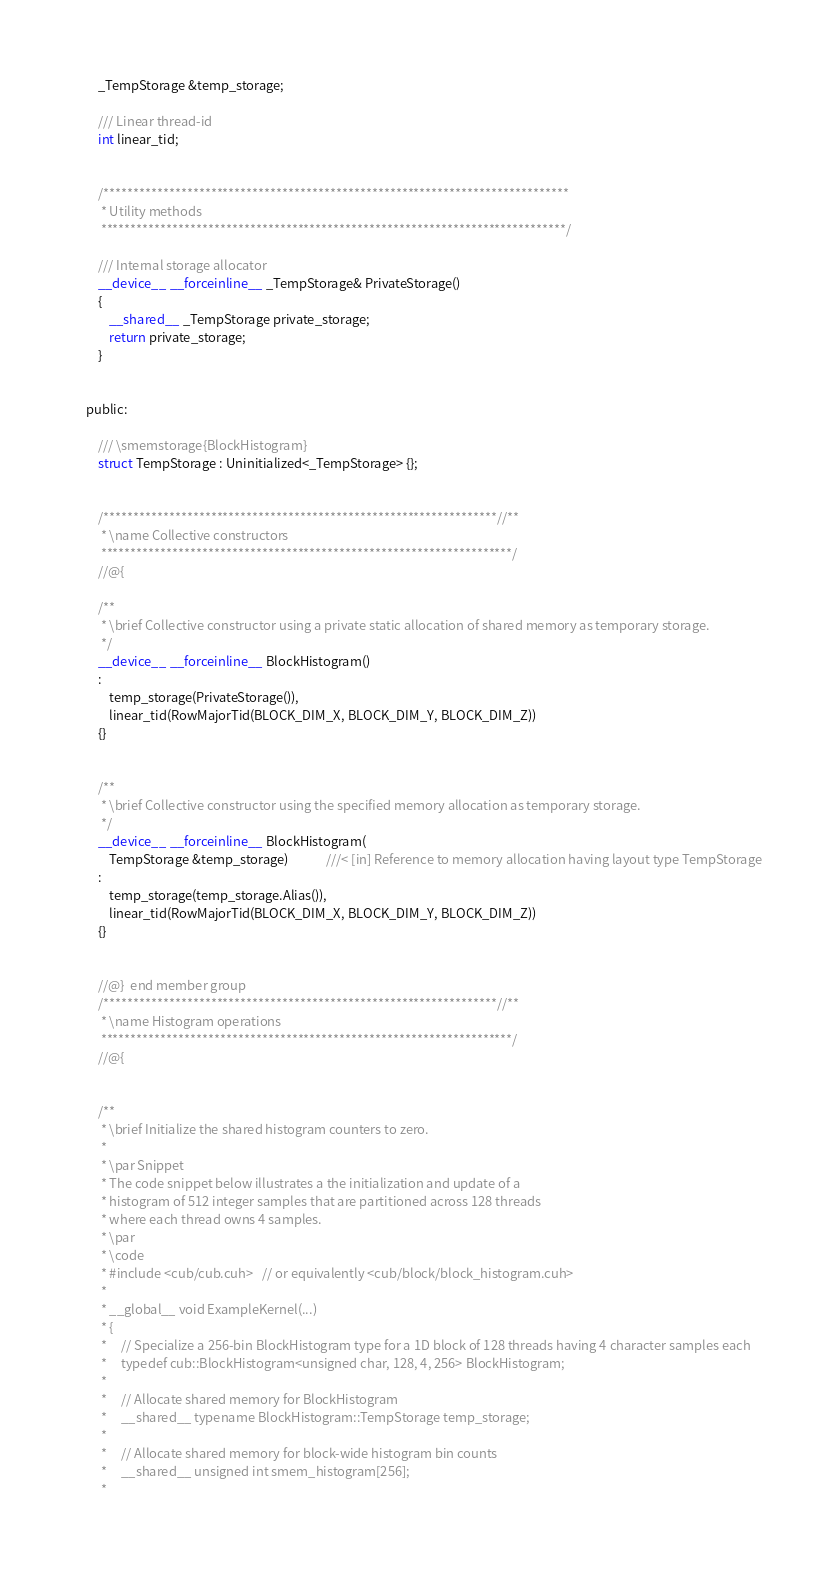Convert code to text. <code><loc_0><loc_0><loc_500><loc_500><_Cuda_>    _TempStorage &temp_storage;

    /// Linear thread-id
    int linear_tid;


    /******************************************************************************
     * Utility methods
     ******************************************************************************/

    /// Internal storage allocator
    __device__ __forceinline__ _TempStorage& PrivateStorage()
    {
        __shared__ _TempStorage private_storage;
        return private_storage;
    }


public:

    /// \smemstorage{BlockHistogram}
    struct TempStorage : Uninitialized<_TempStorage> {};


    /******************************************************************//**
     * \name Collective constructors
     *********************************************************************/
    //@{

    /**
     * \brief Collective constructor using a private static allocation of shared memory as temporary storage.
     */
    __device__ __forceinline__ BlockHistogram()
    :
        temp_storage(PrivateStorage()),
        linear_tid(RowMajorTid(BLOCK_DIM_X, BLOCK_DIM_Y, BLOCK_DIM_Z))
    {}


    /**
     * \brief Collective constructor using the specified memory allocation as temporary storage.
     */
    __device__ __forceinline__ BlockHistogram(
        TempStorage &temp_storage)             ///< [in] Reference to memory allocation having layout type TempStorage
    :
        temp_storage(temp_storage.Alias()),
        linear_tid(RowMajorTid(BLOCK_DIM_X, BLOCK_DIM_Y, BLOCK_DIM_Z))
    {}


    //@}  end member group
    /******************************************************************//**
     * \name Histogram operations
     *********************************************************************/
    //@{


    /**
     * \brief Initialize the shared histogram counters to zero.
     *
     * \par Snippet
     * The code snippet below illustrates a the initialization and update of a
     * histogram of 512 integer samples that are partitioned across 128 threads
     * where each thread owns 4 samples.
     * \par
     * \code
     * #include <cub/cub.cuh>   // or equivalently <cub/block/block_histogram.cuh>
     *
     * __global__ void ExampleKernel(...)
     * {
     *     // Specialize a 256-bin BlockHistogram type for a 1D block of 128 threads having 4 character samples each
     *     typedef cub::BlockHistogram<unsigned char, 128, 4, 256> BlockHistogram;
     *
     *     // Allocate shared memory for BlockHistogram
     *     __shared__ typename BlockHistogram::TempStorage temp_storage;
     *
     *     // Allocate shared memory for block-wide histogram bin counts
     *     __shared__ unsigned int smem_histogram[256];
     *</code> 